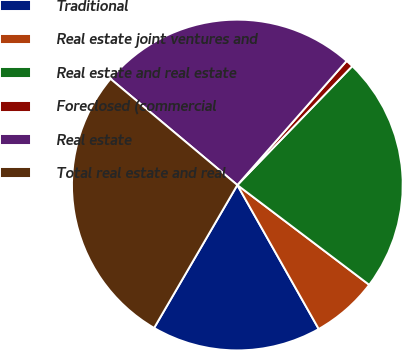Convert chart to OTSL. <chart><loc_0><loc_0><loc_500><loc_500><pie_chart><fcel>Traditional<fcel>Real estate joint ventures and<fcel>Real estate and real estate<fcel>Foreclosed (commercial<fcel>Real estate<fcel>Total real estate and real<nl><fcel>16.58%<fcel>6.5%<fcel>23.08%<fcel>0.74%<fcel>25.39%<fcel>27.7%<nl></chart> 